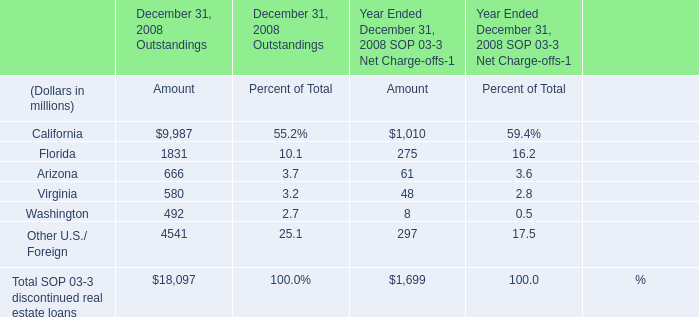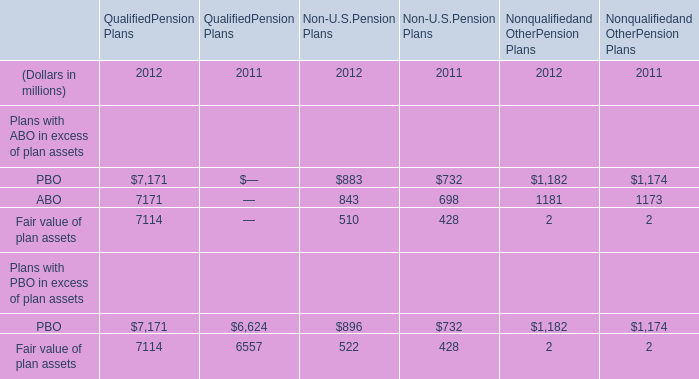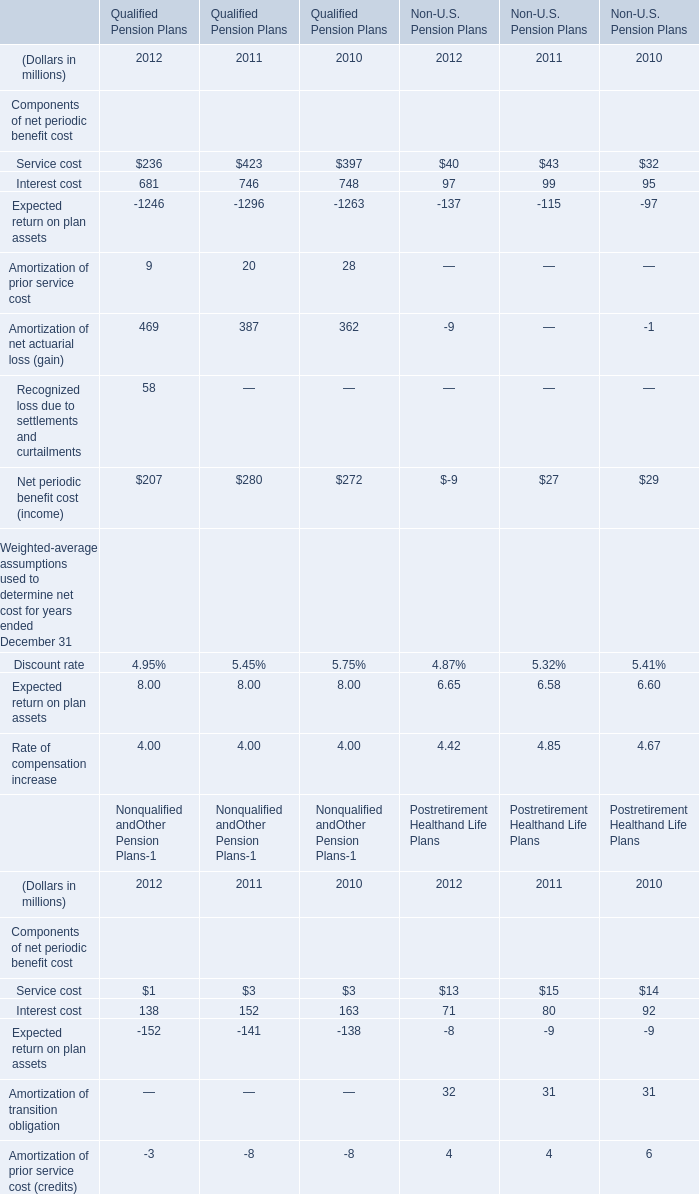What is the sum of ABO of Non-U.S.Pension Plans in 2012 and Service cost of Qualified Pension Plans in 2011? (in million) 
Computations: (843 + 423)
Answer: 1266.0. 